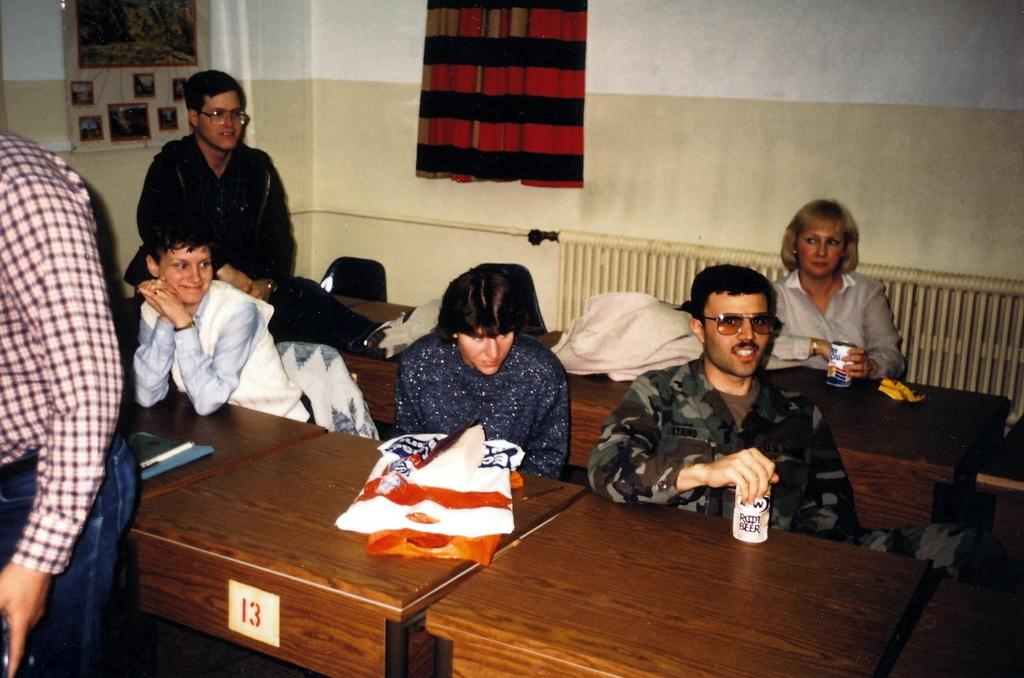What is the setting of the image? The image is of the inside of a room. Who or what can be seen in the room? There is a group of people in the image. What objects are present on the table? There are covers, books, and bottles on the table. What is located at the back of the room? There is a chart and a curtain at the back of the room. What action is the porter performing in the image? There is no porter present in the image, so no action can be attributed to a porter. 